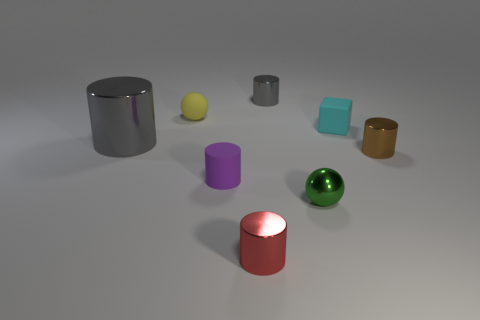Subtract all shiny cylinders. How many cylinders are left? 1 Subtract all purple cylinders. How many cylinders are left? 4 Subtract 1 balls. How many balls are left? 1 Add 1 matte balls. How many objects exist? 9 Subtract all cylinders. How many objects are left? 3 Add 7 tiny green spheres. How many tiny green spheres are left? 8 Add 4 small gray metal cylinders. How many small gray metal cylinders exist? 5 Subtract 0 brown spheres. How many objects are left? 8 Subtract all gray cylinders. Subtract all cyan cubes. How many cylinders are left? 3 Subtract all yellow spheres. How many red cylinders are left? 1 